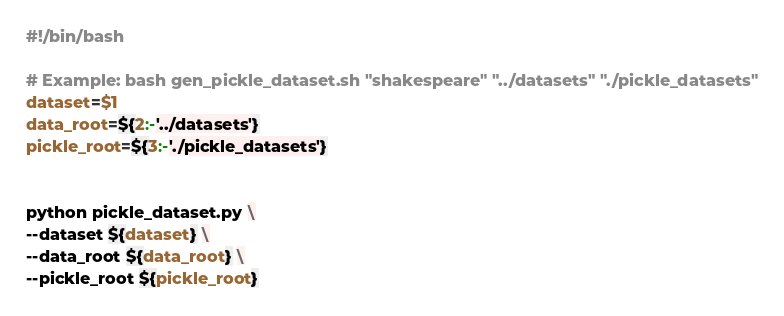<code> <loc_0><loc_0><loc_500><loc_500><_Bash_>#!/bin/bash

# Example: bash gen_pickle_dataset.sh "shakespeare" "../datasets" "./pickle_datasets"
dataset=$1
data_root=${2:-'../datasets'}
pickle_root=${3:-'./pickle_datasets'}


python pickle_dataset.py \
--dataset ${dataset} \
--data_root ${data_root} \
--pickle_root ${pickle_root}
</code> 